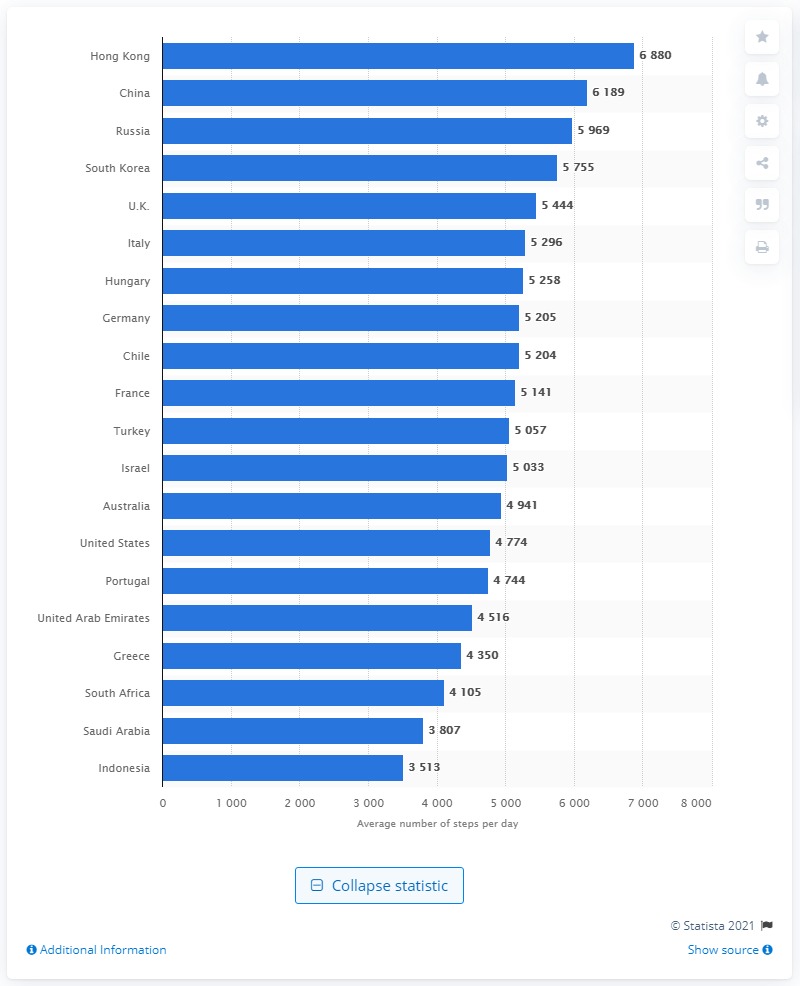List a handful of essential elements in this visual. Hong Kong had the highest average daily step counts among all countries, according to a recent study. 